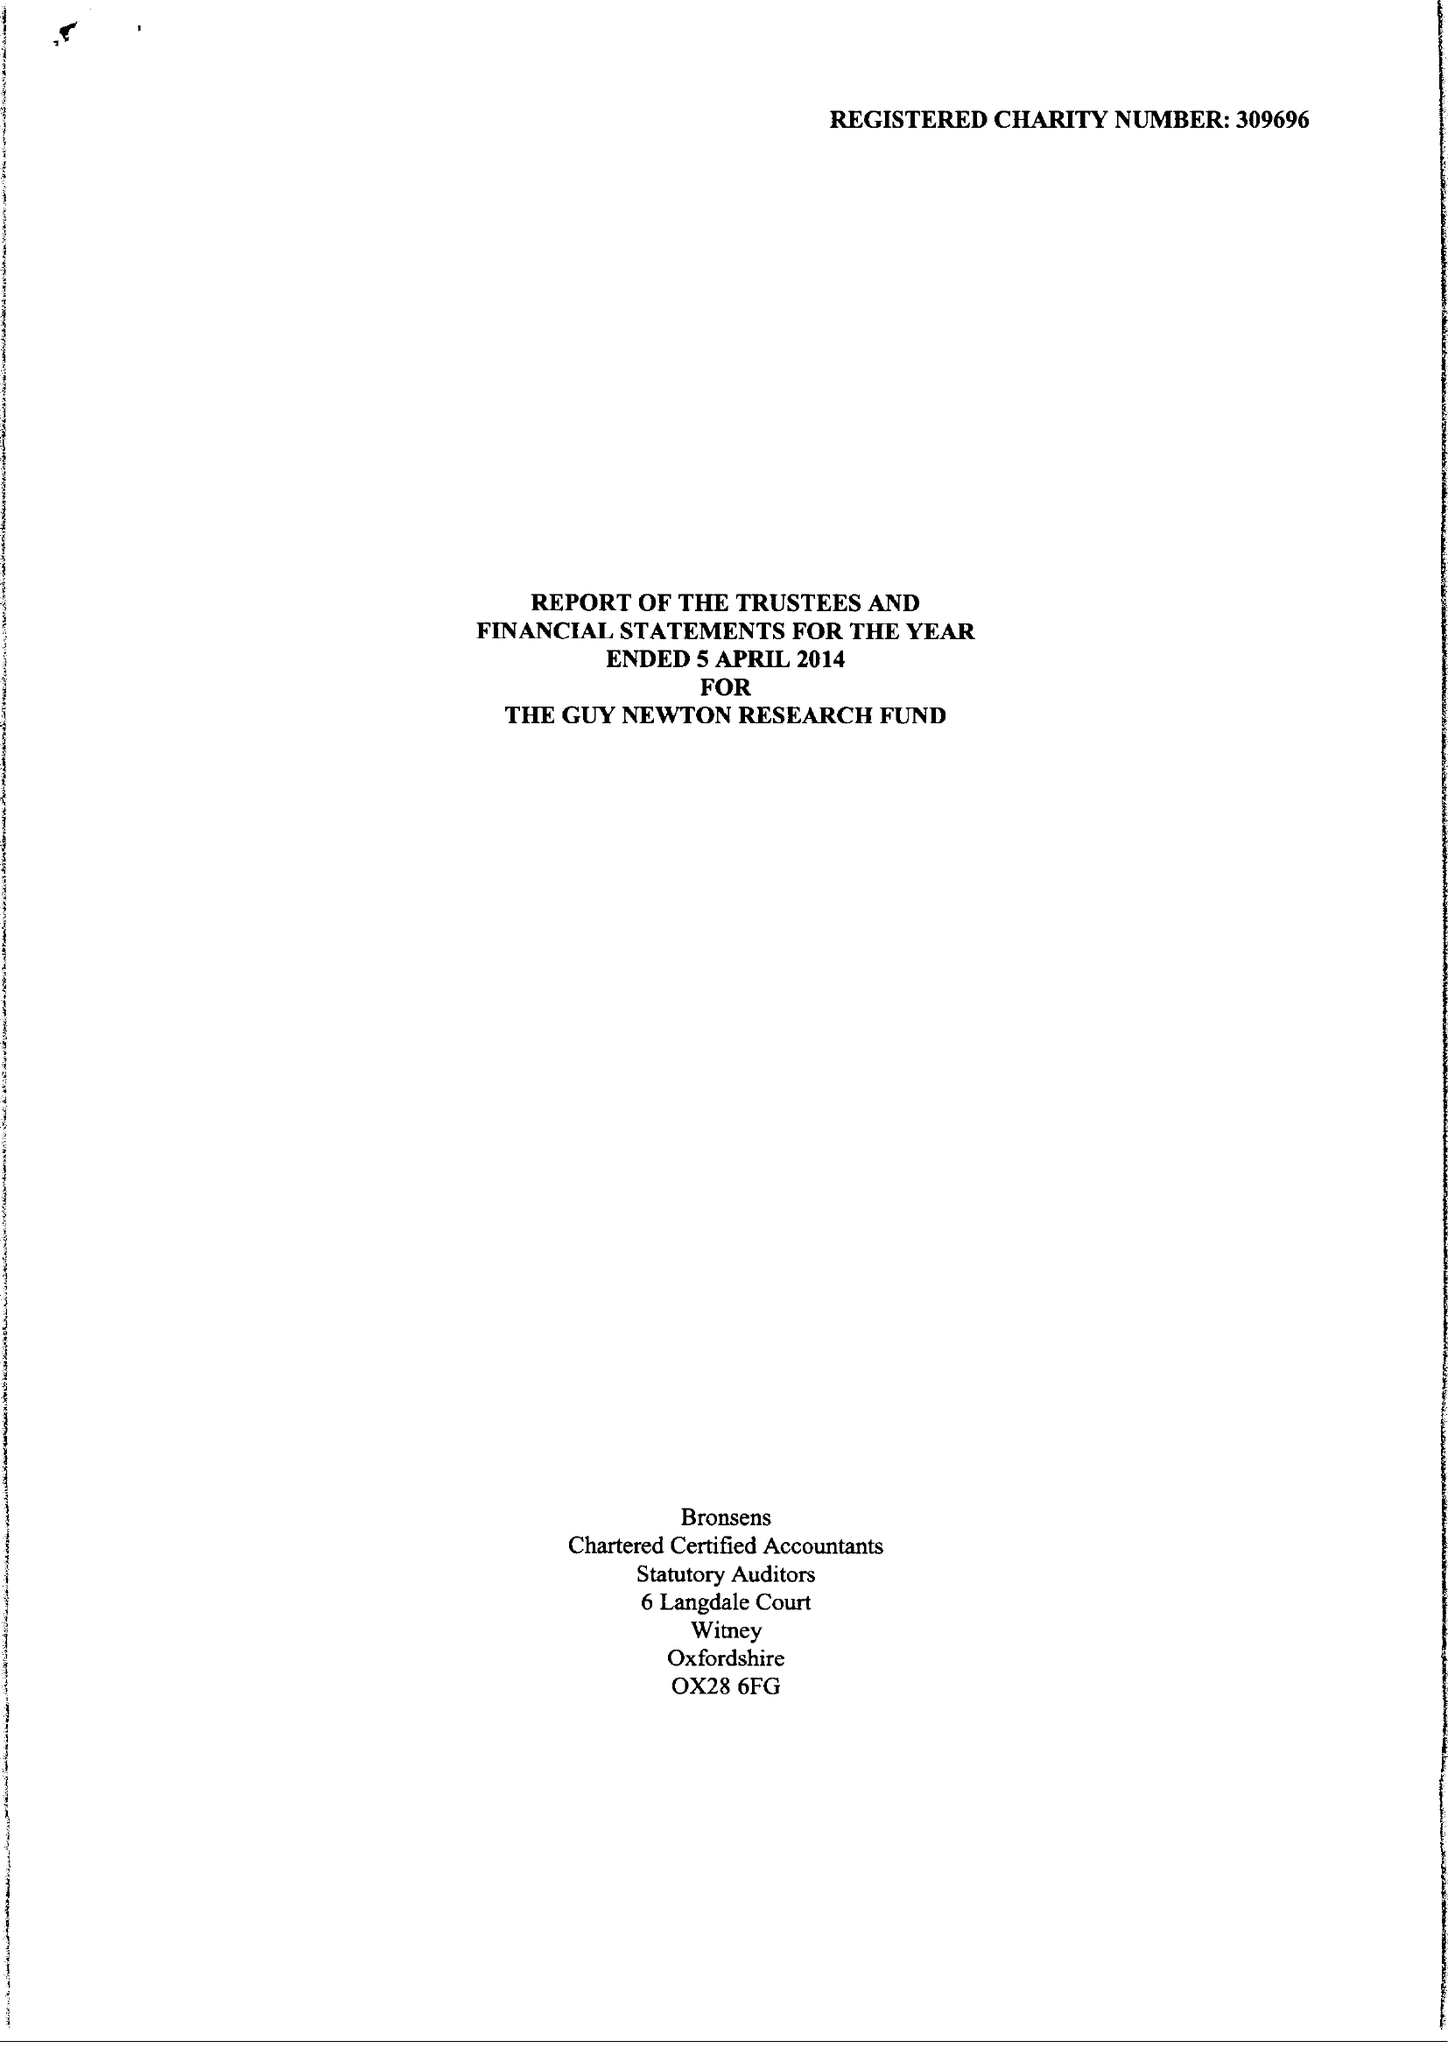What is the value for the spending_annually_in_british_pounds?
Answer the question using a single word or phrase. 46320.00 